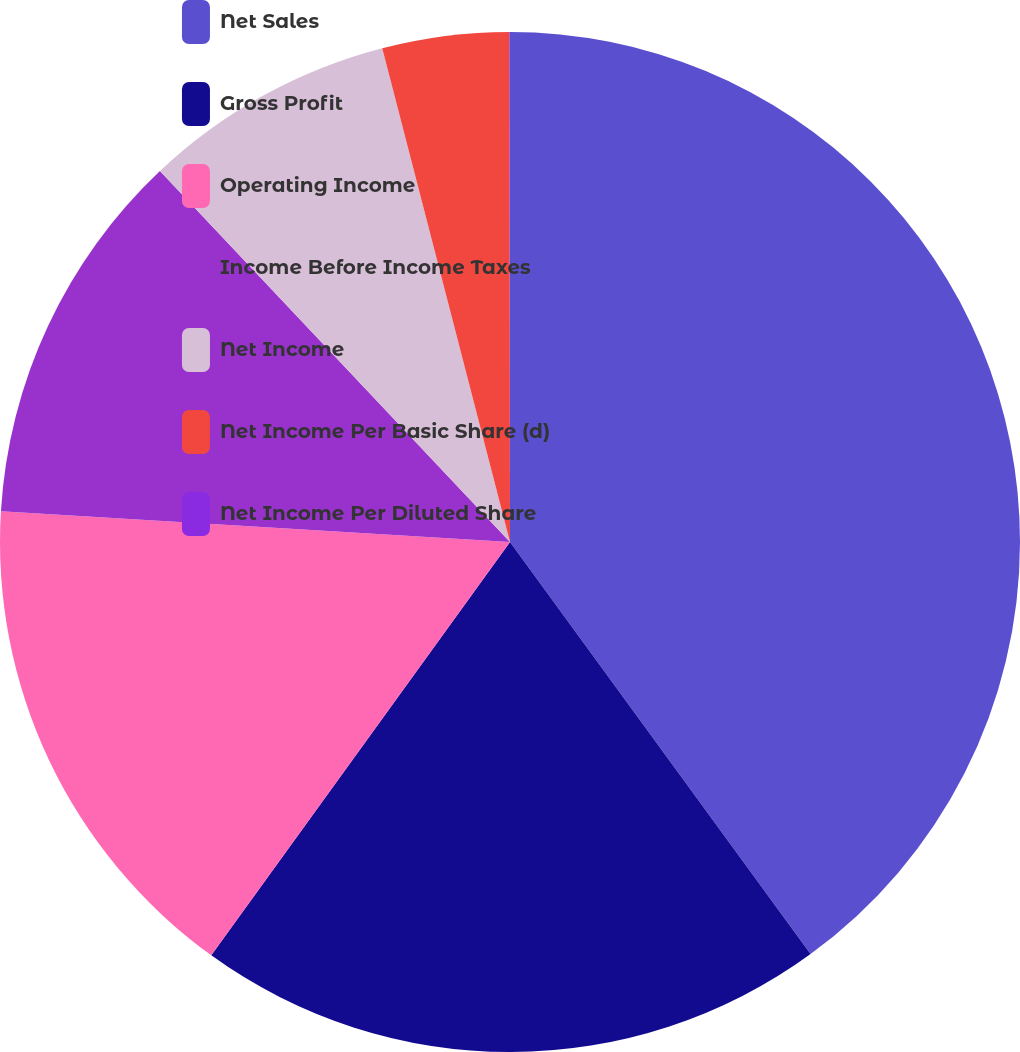Convert chart to OTSL. <chart><loc_0><loc_0><loc_500><loc_500><pie_chart><fcel>Net Sales<fcel>Gross Profit<fcel>Operating Income<fcel>Income Before Income Taxes<fcel>Net Income<fcel>Net Income Per Basic Share (d)<fcel>Net Income Per Diluted Share<nl><fcel>39.97%<fcel>19.99%<fcel>16.0%<fcel>12.0%<fcel>8.01%<fcel>4.01%<fcel>0.02%<nl></chart> 